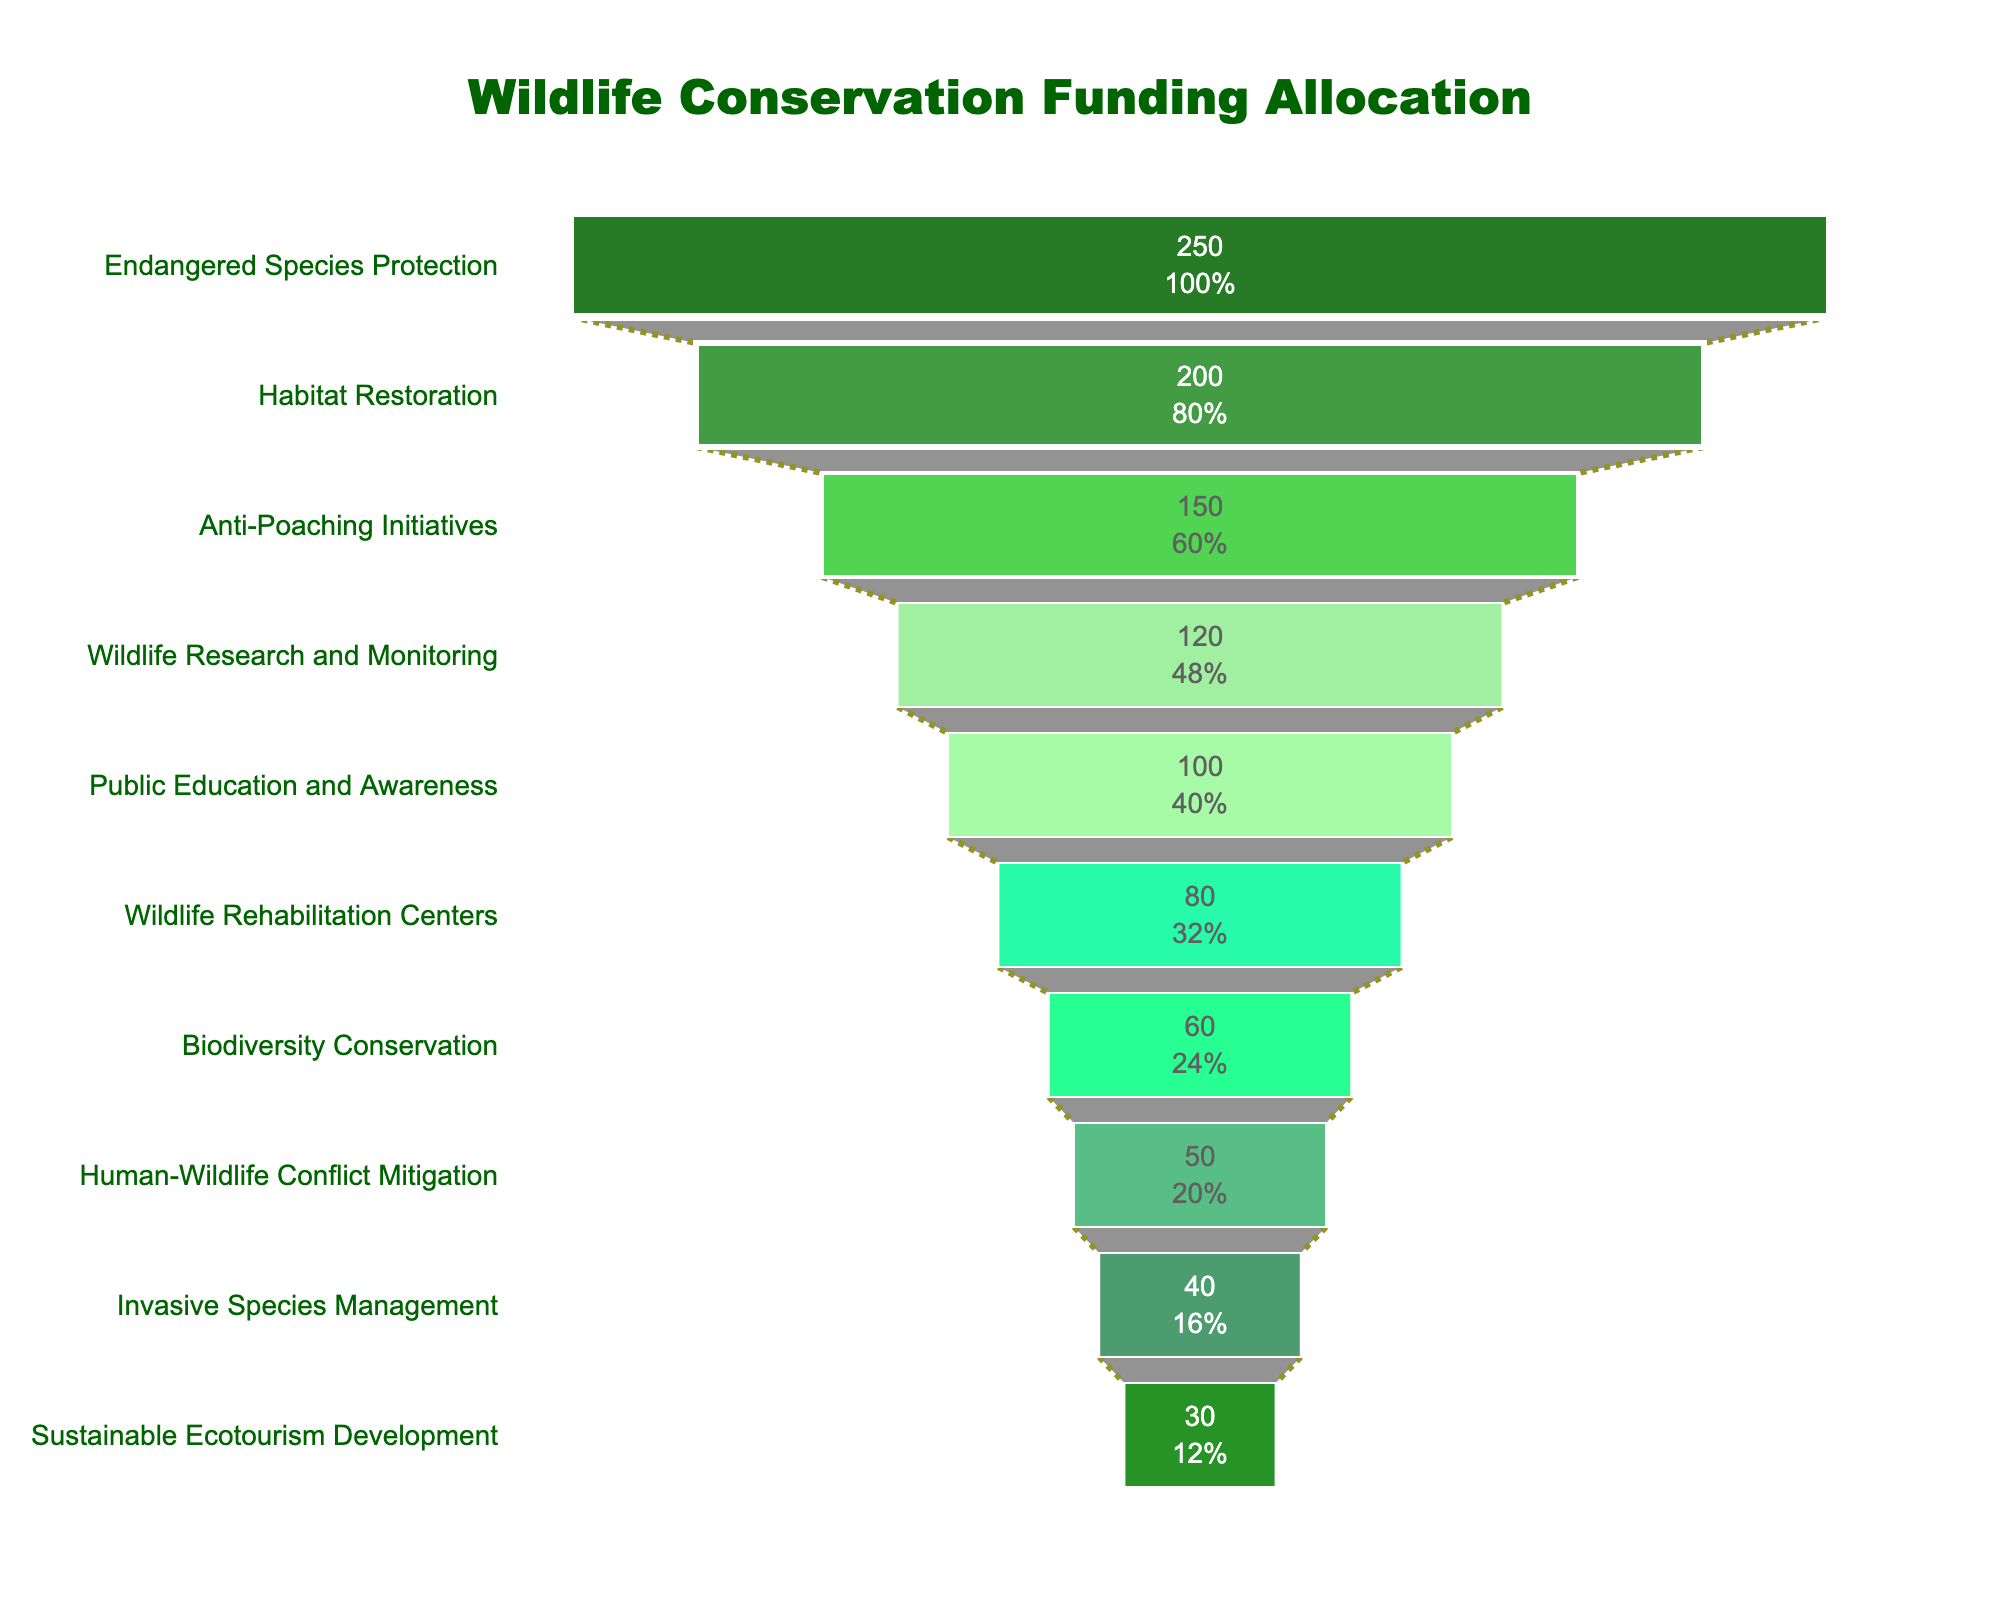What is the title of the funnel chart? The title can be found at the top-center of the chart. It reads "Wildlife Conservation Funding Allocation".
Answer: Wildlife Conservation Funding Allocation How much funding is allocated to Habitat Restoration? The amount allocated to Habitat Restoration is displayed inside the corresponding section of the funnel.
Answer: 200 million USD Which project received the least amount of funding? The lowest segment of the funnel chart represents the project with the least funding, "Sustainable Ecotourism Development".
Answer: Sustainable Ecotourism Development What is the total funding allocated across all projects? To find the total, sum the funding amounts for all projects: 250 + 200 + 150 + 120 + 100 + 80 + 60 + 50 + 40 + 30 = 1080 million USD.
Answer: 1080 million USD How many projects have funding greater than or equal to 100 million USD? Count the segments in the funnel chart with funding amounts of 100 million USD or more: Endangered Species Protection, Habitat Restoration, Anti-Poaching Initiatives, Wildlife Research and Monitoring, and Public Education and Awareness. There are 5 such projects.
Answer: 5 Which two projects have a combined funding amount exactly equal to 100 million USD? To find the projects whose combined funding equals 100 million USD, look for pairs that sum to 100. "Biodiversity Conservation" (60) and "Human-Wildlife Conflict Mitigation" (50) sum to 110 and do not count. "Wildlife Rehabilitation Centers" (80) and "Sustainable Ecotourism Development" (30) do.
Answer: Wildlife Rehabilitation Centers and Sustainable Ecotourism Development What percentage of the total funding is allocated to Anti-Poaching Initiatives? First, determine the total funding, which is 1080 million USD. Next, divide the Anti-Poaching Initiatives funding by the total and multiply by 100: (150 / 1080) * 100 ≈ 13.89%.
Answer: 13.89% How much more funding is allocated to Endangered Species Protection compared to Wildlife Rehabilitation Centers? Subtract the Wildlife Rehabilitation Centers funding from the Endangered Species Protection funding: 250 - 80 = 170 million USD.
Answer: 170 million USD Which project has a funding amount twice as much as Sustainable Ecotourism Development? The Sustainable Ecotourism Development project receives 30 million USD. The project with double this amount is Invasive Species Management, which has 60 million USD.
Answer: Invasive Species Management What is the average funding amount for the projects receiving less than 100 million USD? Identify the projects with less than 100 million USD funding and sum their amounts: 80 + 60 + 50 + 40 + 30 = 260. There are 5 such projects, so divide the sum by 5: 260 / 5 = 52 million USD.
Answer: 52 million USD 